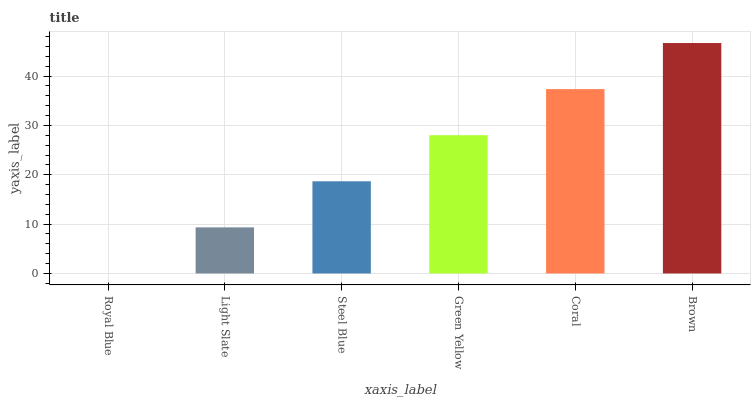Is Light Slate the minimum?
Answer yes or no. No. Is Light Slate the maximum?
Answer yes or no. No. Is Light Slate greater than Royal Blue?
Answer yes or no. Yes. Is Royal Blue less than Light Slate?
Answer yes or no. Yes. Is Royal Blue greater than Light Slate?
Answer yes or no. No. Is Light Slate less than Royal Blue?
Answer yes or no. No. Is Green Yellow the high median?
Answer yes or no. Yes. Is Steel Blue the low median?
Answer yes or no. Yes. Is Steel Blue the high median?
Answer yes or no. No. Is Green Yellow the low median?
Answer yes or no. No. 